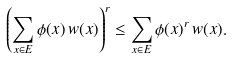Convert formula to latex. <formula><loc_0><loc_0><loc_500><loc_500>\left ( \sum _ { x \in E } \phi ( x ) \, w ( x ) \right ) ^ { r } \leq \sum _ { x \in E } \phi ( x ) ^ { r } \, w ( x ) .</formula> 